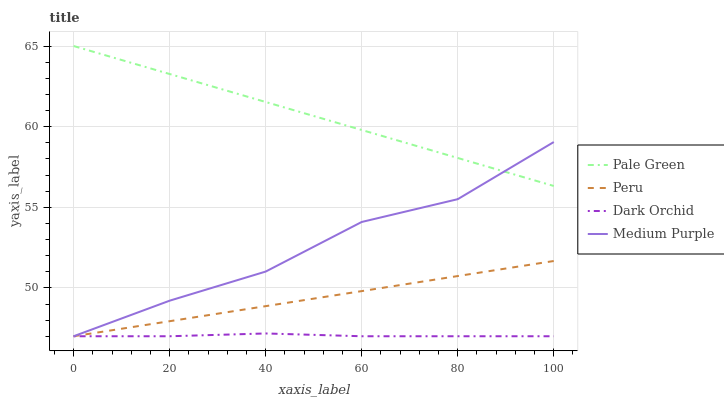Does Dark Orchid have the minimum area under the curve?
Answer yes or no. Yes. Does Pale Green have the maximum area under the curve?
Answer yes or no. Yes. Does Pale Green have the minimum area under the curve?
Answer yes or no. No. Does Dark Orchid have the maximum area under the curve?
Answer yes or no. No. Is Pale Green the smoothest?
Answer yes or no. Yes. Is Medium Purple the roughest?
Answer yes or no. Yes. Is Dark Orchid the smoothest?
Answer yes or no. No. Is Dark Orchid the roughest?
Answer yes or no. No. Does Medium Purple have the lowest value?
Answer yes or no. Yes. Does Pale Green have the lowest value?
Answer yes or no. No. Does Pale Green have the highest value?
Answer yes or no. Yes. Does Dark Orchid have the highest value?
Answer yes or no. No. Is Dark Orchid less than Pale Green?
Answer yes or no. Yes. Is Pale Green greater than Dark Orchid?
Answer yes or no. Yes. Does Medium Purple intersect Dark Orchid?
Answer yes or no. Yes. Is Medium Purple less than Dark Orchid?
Answer yes or no. No. Is Medium Purple greater than Dark Orchid?
Answer yes or no. No. Does Dark Orchid intersect Pale Green?
Answer yes or no. No. 